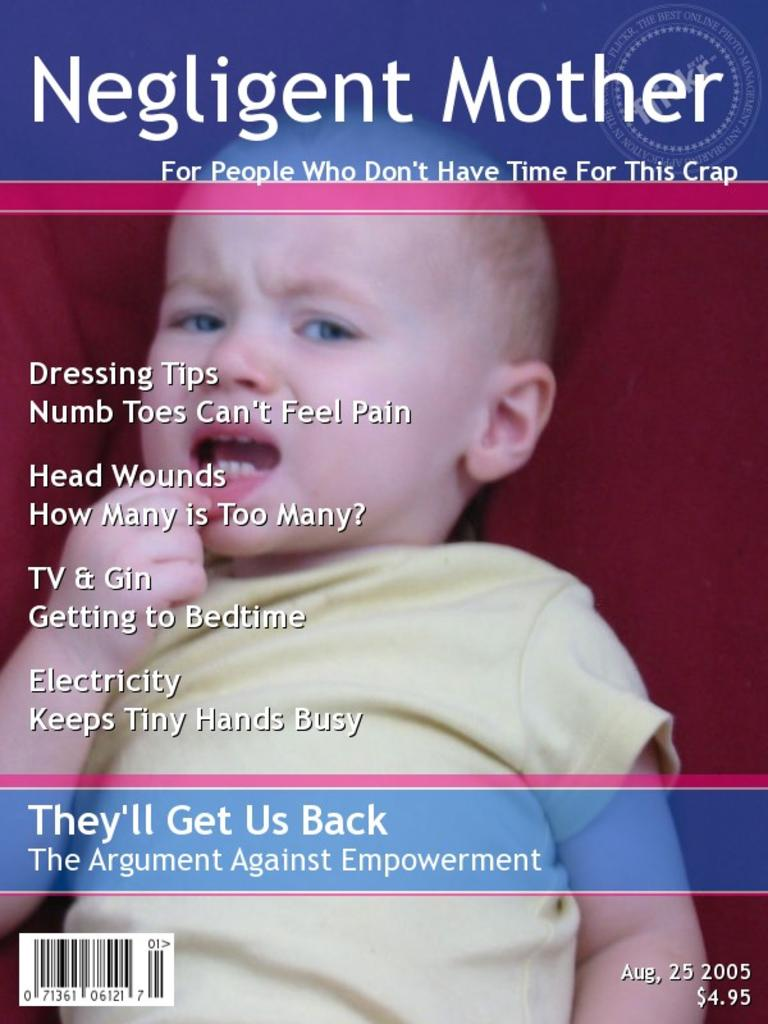What is the main subject of the image? The main subject of the image is a cover paper. What is depicted on the cover paper? There is a baby depicted on the paper. Are there any words or letters on the cover paper? Yes, there is text on the paper. What type of trip is the baby taking in the image? There is no indication of a trip in the image; it simply shows a baby depicted on a cover paper with text. How many times does the baby smash the downtown area in the image? There is no downtown area or smashing depicted in the image; it only features a baby on a cover paper with text. 